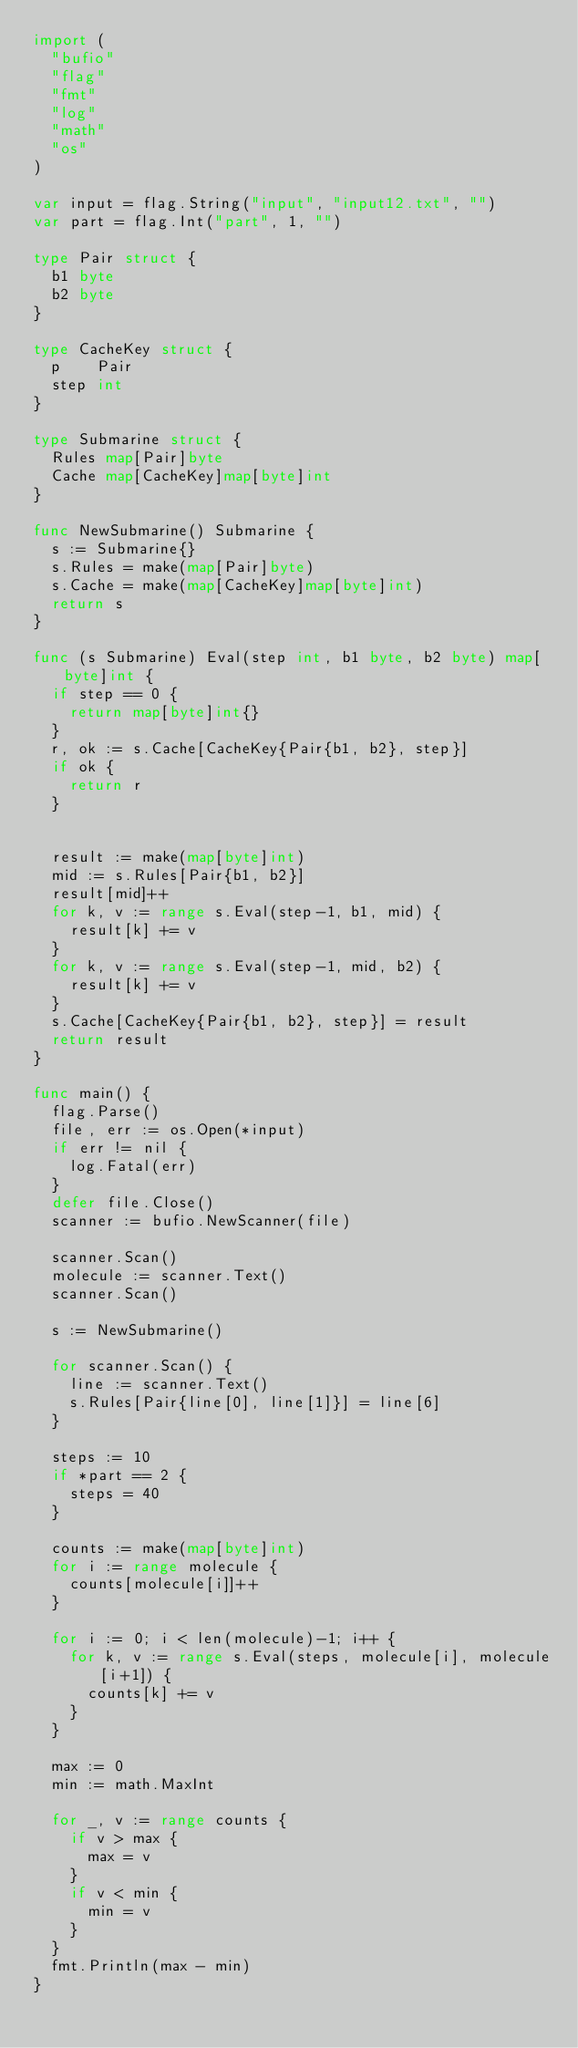<code> <loc_0><loc_0><loc_500><loc_500><_Go_>import (
	"bufio"
	"flag"
	"fmt"
	"log"
	"math"
	"os"
)

var input = flag.String("input", "input12.txt", "")
var part = flag.Int("part", 1, "")

type Pair struct {
	b1 byte
	b2 byte
}

type CacheKey struct {
	p    Pair
	step int
}

type Submarine struct {
	Rules map[Pair]byte
	Cache map[CacheKey]map[byte]int
}

func NewSubmarine() Submarine {
	s := Submarine{}
	s.Rules = make(map[Pair]byte)
	s.Cache = make(map[CacheKey]map[byte]int)
	return s
}

func (s Submarine) Eval(step int, b1 byte, b2 byte) map[byte]int {
	if step == 0 {
		return map[byte]int{}
	}
	r, ok := s.Cache[CacheKey{Pair{b1, b2}, step}]
	if ok {
		return r
	}


	result := make(map[byte]int)
	mid := s.Rules[Pair{b1, b2}]
	result[mid]++
	for k, v := range s.Eval(step-1, b1, mid) {
		result[k] += v
	}
	for k, v := range s.Eval(step-1, mid, b2) {
		result[k] += v
	}
	s.Cache[CacheKey{Pair{b1, b2}, step}] = result
	return result
}

func main() {
	flag.Parse()
	file, err := os.Open(*input)
	if err != nil {
		log.Fatal(err)
	}
	defer file.Close()
	scanner := bufio.NewScanner(file)

	scanner.Scan()
	molecule := scanner.Text()
	scanner.Scan()

	s := NewSubmarine()

	for scanner.Scan() {
		line := scanner.Text()
		s.Rules[Pair{line[0], line[1]}] = line[6]
	}

	steps := 10
	if *part == 2 {
		steps = 40
	}

	counts := make(map[byte]int)
	for i := range molecule {
		counts[molecule[i]]++
	}

	for i := 0; i < len(molecule)-1; i++ {
		for k, v := range s.Eval(steps, molecule[i], molecule[i+1]) {
			counts[k] += v
		}
	}

	max := 0
	min := math.MaxInt

	for _, v := range counts {
		if v > max {
			max = v
		}
		if v < min {
			min = v
		}
	}
	fmt.Println(max - min)
}
</code> 